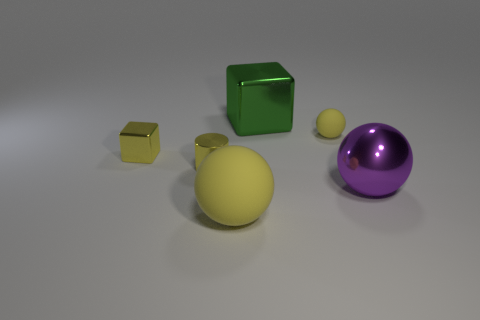There is a yellow ball in front of the metallic cylinder; what is its size?
Your response must be concise. Large. The big matte object that is the same color as the small rubber thing is what shape?
Offer a very short reply. Sphere. There is a object behind the yellow ball behind the large sphere to the left of the green object; what shape is it?
Your answer should be compact. Cube. How many other objects are the same shape as the large matte object?
Your answer should be very brief. 2. How many metal objects are either red cylinders or large purple spheres?
Offer a terse response. 1. There is a block that is behind the block that is left of the yellow metal cylinder; what is it made of?
Your answer should be compact. Metal. Are there more tiny yellow things that are on the right side of the big green metallic block than big red balls?
Your answer should be very brief. Yes. Are there any brown cubes made of the same material as the large purple thing?
Provide a short and direct response. No. There is a large yellow matte thing that is to the left of the green cube; does it have the same shape as the large green thing?
Provide a succinct answer. No. How many tiny metallic objects are to the right of the cube that is in front of the yellow matte sphere that is behind the metallic sphere?
Offer a very short reply. 1. 